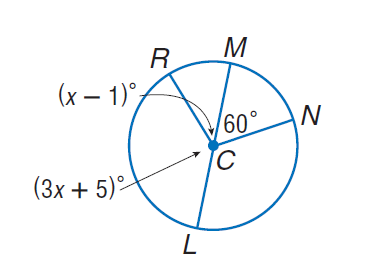Answer the mathemtical geometry problem and directly provide the correct option letter.
Question: Find m \angle R C L.
Choices: A: 43 B: 137 C: 223 D: 247 B 